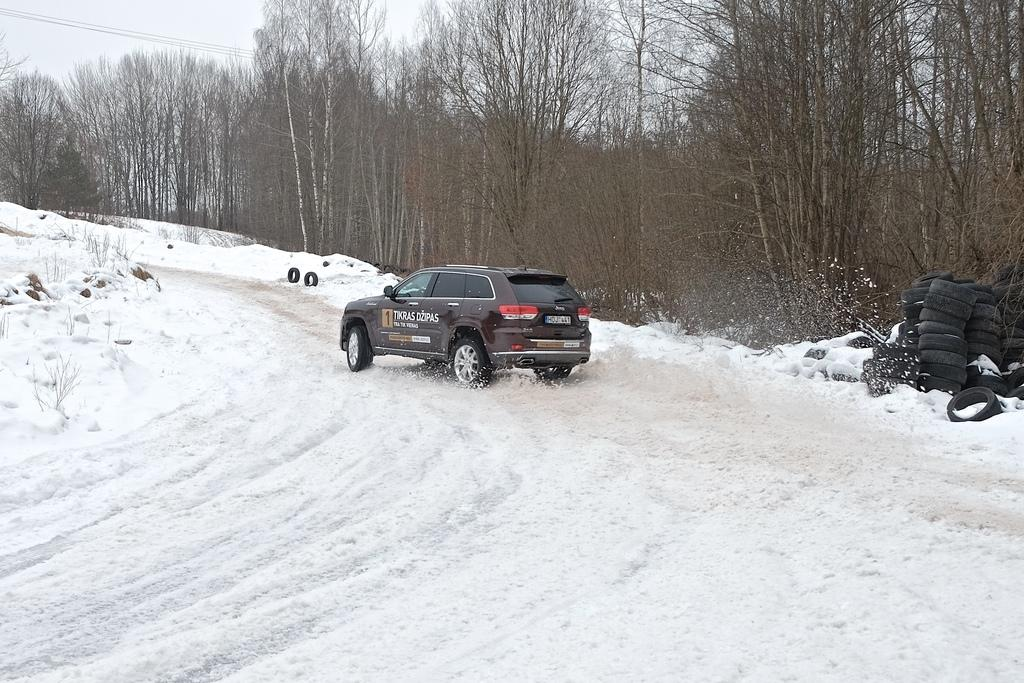What is the weather condition depicted in the image? There is snow in the image, indicating a cold and wintry scene. What vehicle is present in the image? There is a car in the image. What part of the car is designed for traction and movement? The car has tyres for traction and movement. What type of natural vegetation can be seen in the image? There are trees in the image. What is visible in the background of the image? The sky is visible in the image. What word is written on the dime that is visible in the image? There is no dime present in the image; it only features snow, a car, trees, and the sky. How long does the car need to rest before continuing its journey in the image? The image does not provide information about the car's journey or the need for rest, as it only shows the car in a stationary position. 